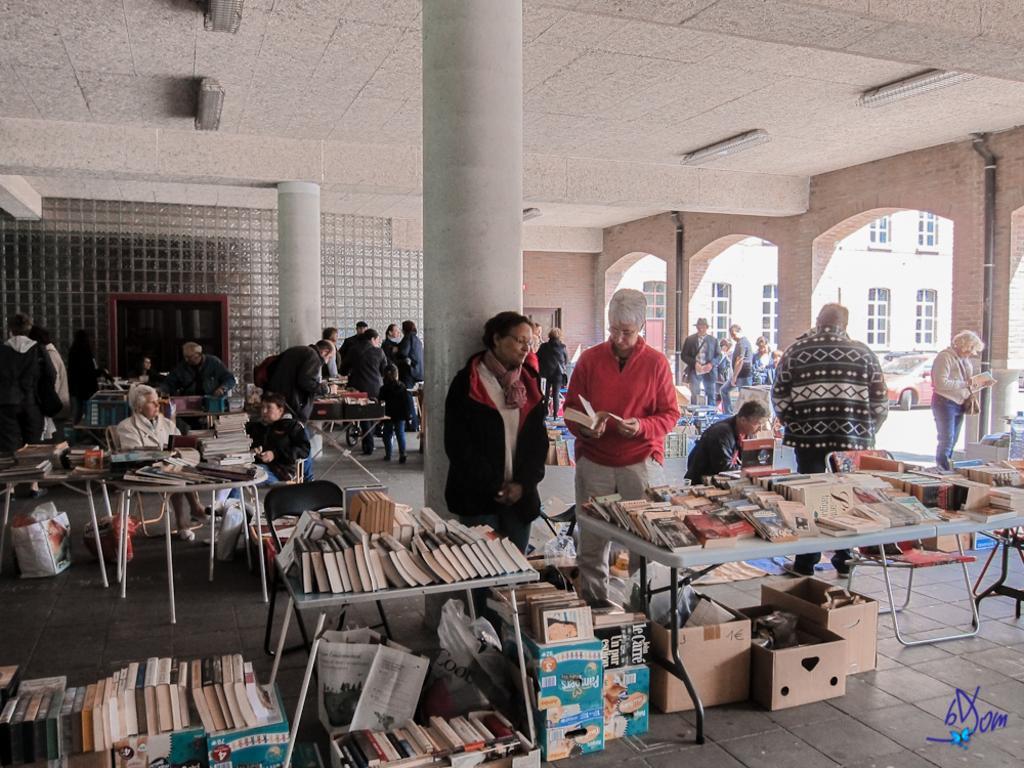Can you describe this image briefly? There are many people in this picture who are reading books and sitting on the table. In the background we observe a glass door and to the right of the image there is a building which has glass windows and a car. 